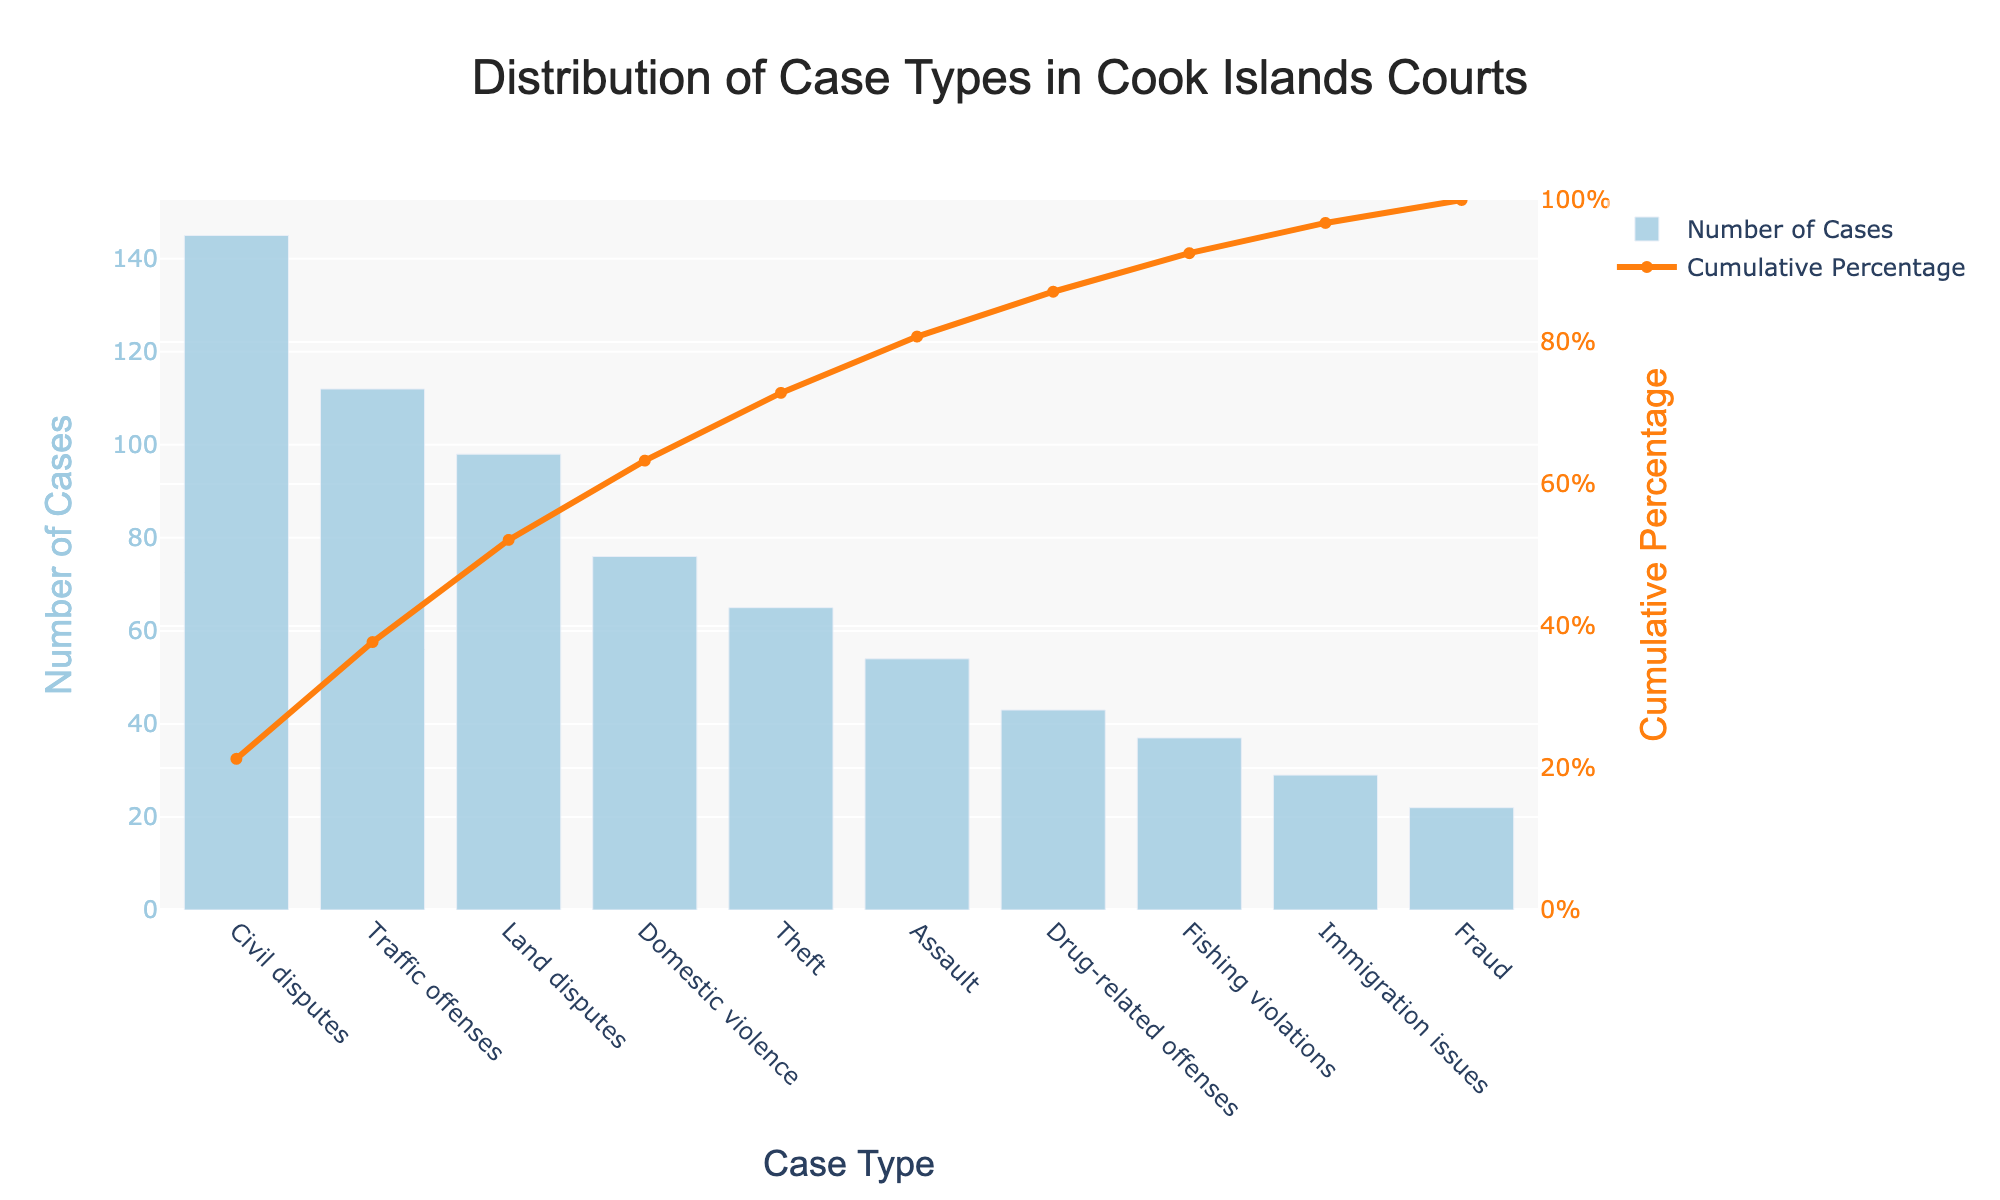Which case type has the highest number of cases? The case type with the highest number of cases is at the highest bar position. Looking at the chart, the tallest bar belongs to "Civil disputes."
Answer: Civil disputes What is the title of the chart? The title of the chart can be found at the top center of the visual. The given title is "Distribution of Case Types in Cook Islands Courts."
Answer: Distribution of Case Types in Cook Islands Courts How many case types have fewer than 50 cases? Examine the lengths of the bars to determine which are lower than the 50 mark on the y-axis. The case types with fewer than 50 cases are "Drug-related offenses," "Fishing violations," "Immigration issues," and "Fraud." Therefore, there are 4 case types.
Answer: 4 What is the cumulative percentage when immigration issues are included? Find "Immigration issues" on the x-axis and trace the corresponding cumulative percentage on the line chart, which is accurate to around 97%.
Answer: ~97% What are the case types where the cumulative percentage exceeds 80%? Starting from the left, add the percentages of each case type until the cumulative percentage surpasses 80%. The cumulative percentage surpasses 80% at "Domestic violence." Therefore, the case types include "Civil disputes," "Traffic offenses," "Land disputes," "Domestic violence," and "Theft."
Answer: Civil disputes, Traffic offenses, Land disputes, Domestic violence, Theft How does the number of fraud cases compare to the number of fishing violations? Identify the bar heights for both "Fraud" and "Fishing violations." The "Fishing violations" bar is taller than the "Fraud" bar, indicating more fishing violations compared to fraud cases.
Answer: More fishing violations than fraud What is the cumulative percentage after including theft cases? Locate "Theft" on the x-axis and trace the corresponding cumulative percentage on the line chart, which approximates to 82%.
Answer: ~82% Which case type represents the smallest number of cases, and how many cases does it include? Observe the shortest bar to identify the case type with the smallest number of cases. "Fraud" is the shortest bar, representing 22 cases.
Answer: Fraud, 22 What is the total number of cases for the top three case types? Add the number of cases in the top three bars: "Civil disputes" (145), "Traffic offenses" (112), and "Land disputes" (98). The total is 145 + 112 + 98 = 355.
Answer: 355 What percentage of the total number of cases do the top four case types represent? Calculate cumulative cases for the top four case types ("Civil disputes," "Traffic offenses," "Land disputes," "Domestic violence"), and then determine their percentage. Total cases: 145 + 112 + 98 + 76 = 431. Total cases overall: 700. Percentage: (431/700) * 100 ≈ 61.57%.
Answer: ~61.57% 